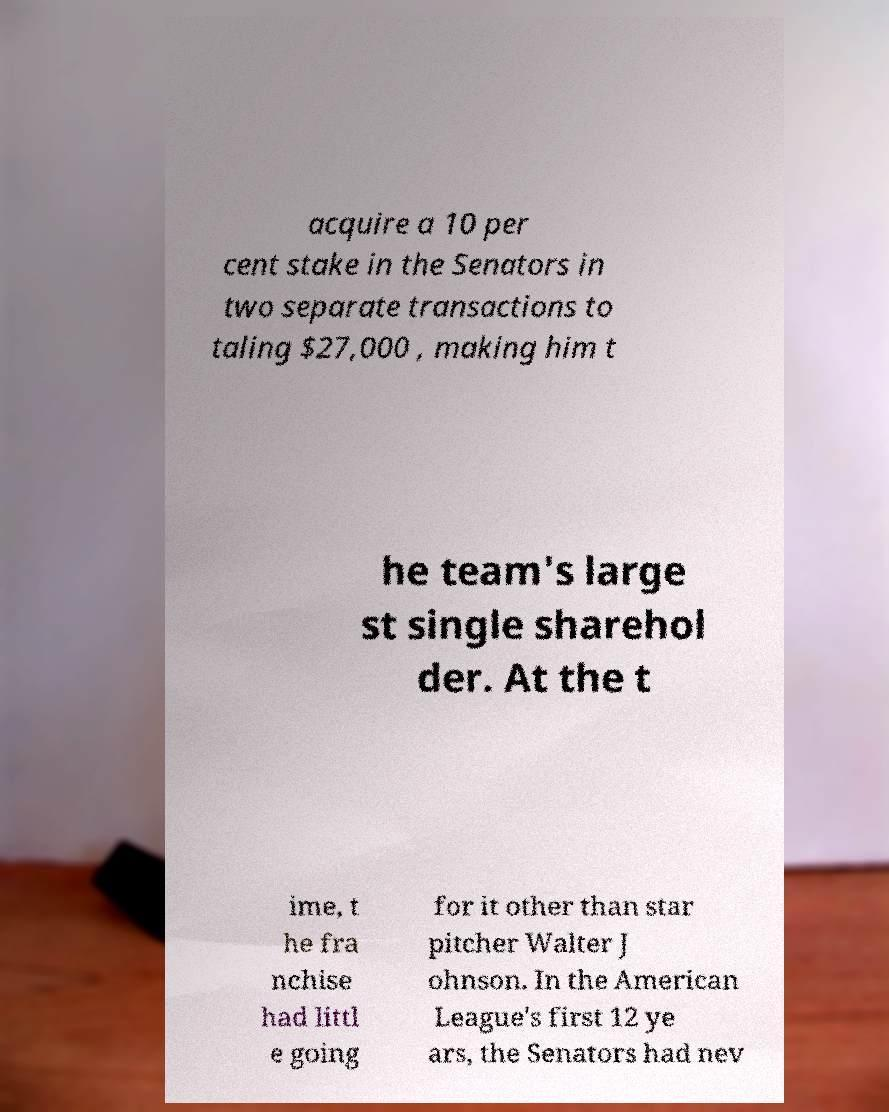For documentation purposes, I need the text within this image transcribed. Could you provide that? acquire a 10 per cent stake in the Senators in two separate transactions to taling $27,000 , making him t he team's large st single sharehol der. At the t ime, t he fra nchise had littl e going for it other than star pitcher Walter J ohnson. In the American League's first 12 ye ars, the Senators had nev 